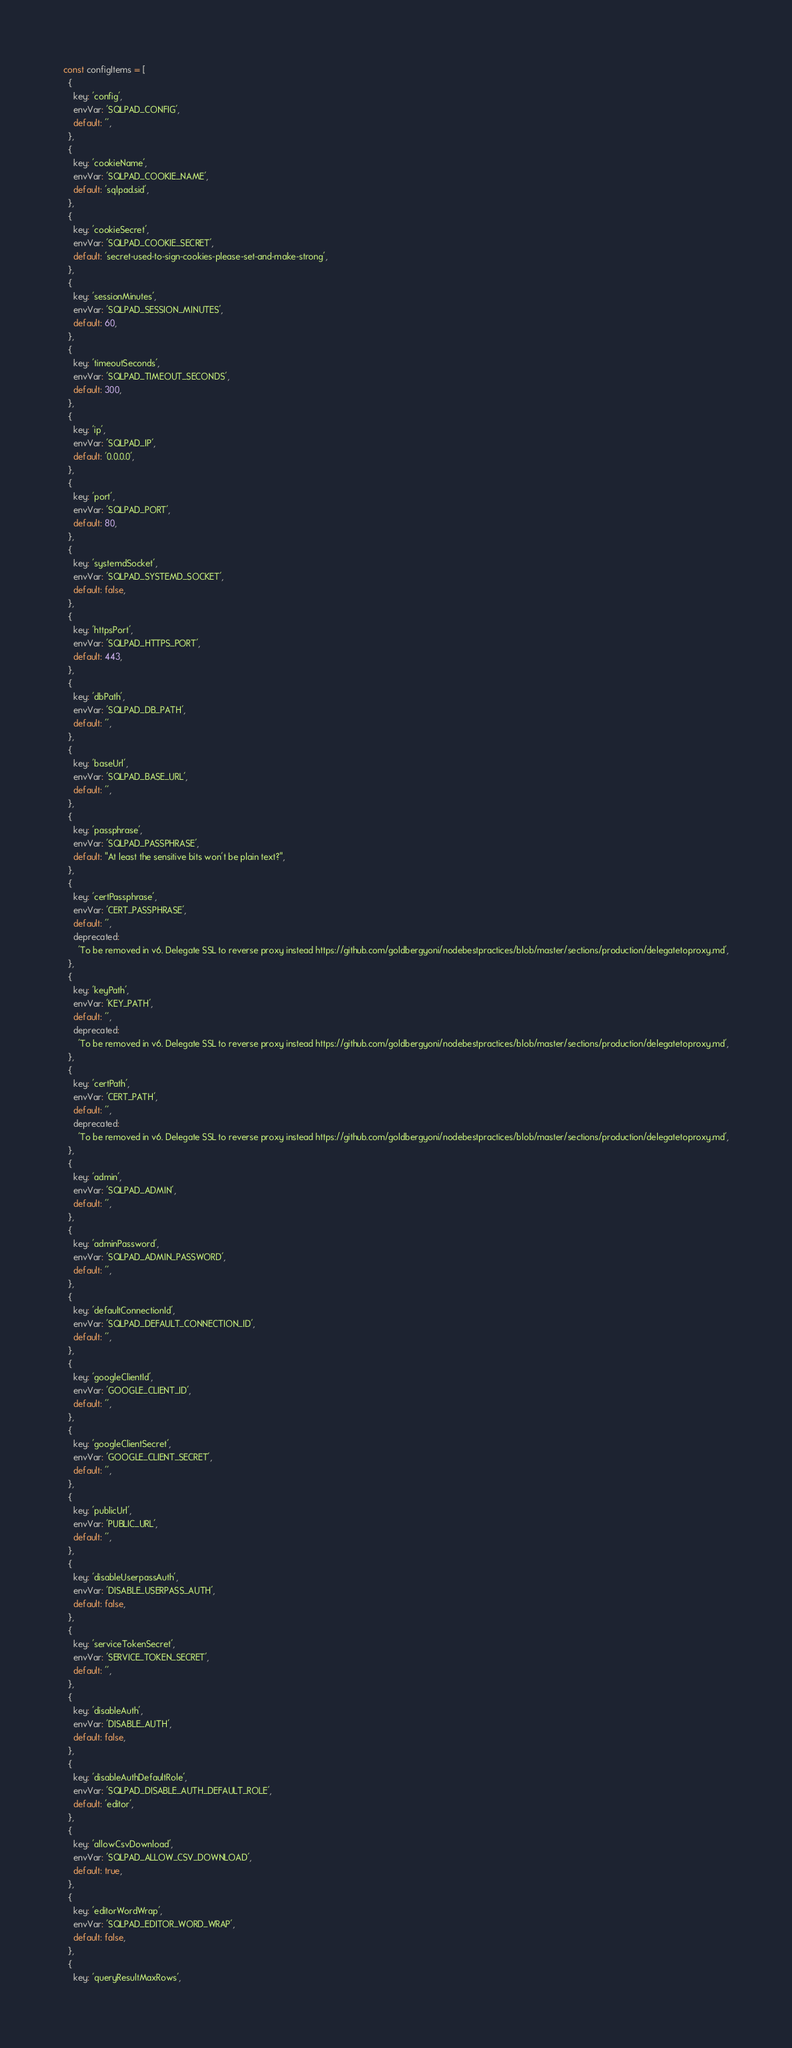Convert code to text. <code><loc_0><loc_0><loc_500><loc_500><_JavaScript_>const configItems = [
  {
    key: 'config',
    envVar: 'SQLPAD_CONFIG',
    default: '',
  },
  {
    key: 'cookieName',
    envVar: 'SQLPAD_COOKIE_NAME',
    default: 'sqlpad.sid',
  },
  {
    key: 'cookieSecret',
    envVar: 'SQLPAD_COOKIE_SECRET',
    default: 'secret-used-to-sign-cookies-please-set-and-make-strong',
  },
  {
    key: 'sessionMinutes',
    envVar: 'SQLPAD_SESSION_MINUTES',
    default: 60,
  },
  {
    key: 'timeoutSeconds',
    envVar: 'SQLPAD_TIMEOUT_SECONDS',
    default: 300,
  },
  {
    key: 'ip',
    envVar: 'SQLPAD_IP',
    default: '0.0.0.0',
  },
  {
    key: 'port',
    envVar: 'SQLPAD_PORT',
    default: 80,
  },
  {
    key: 'systemdSocket',
    envVar: 'SQLPAD_SYSTEMD_SOCKET',
    default: false,
  },
  {
    key: 'httpsPort',
    envVar: 'SQLPAD_HTTPS_PORT',
    default: 443,
  },
  {
    key: 'dbPath',
    envVar: 'SQLPAD_DB_PATH',
    default: '',
  },
  {
    key: 'baseUrl',
    envVar: 'SQLPAD_BASE_URL',
    default: '',
  },
  {
    key: 'passphrase',
    envVar: 'SQLPAD_PASSPHRASE',
    default: "At least the sensitive bits won't be plain text?",
  },
  {
    key: 'certPassphrase',
    envVar: 'CERT_PASSPHRASE',
    default: '',
    deprecated:
      'To be removed in v6. Delegate SSL to reverse proxy instead https://github.com/goldbergyoni/nodebestpractices/blob/master/sections/production/delegatetoproxy.md',
  },
  {
    key: 'keyPath',
    envVar: 'KEY_PATH',
    default: '',
    deprecated:
      'To be removed in v6. Delegate SSL to reverse proxy instead https://github.com/goldbergyoni/nodebestpractices/blob/master/sections/production/delegatetoproxy.md',
  },
  {
    key: 'certPath',
    envVar: 'CERT_PATH',
    default: '',
    deprecated:
      'To be removed in v6. Delegate SSL to reverse proxy instead https://github.com/goldbergyoni/nodebestpractices/blob/master/sections/production/delegatetoproxy.md',
  },
  {
    key: 'admin',
    envVar: 'SQLPAD_ADMIN',
    default: '',
  },
  {
    key: 'adminPassword',
    envVar: 'SQLPAD_ADMIN_PASSWORD',
    default: '',
  },
  {
    key: 'defaultConnectionId',
    envVar: 'SQLPAD_DEFAULT_CONNECTION_ID',
    default: '',
  },
  {
    key: 'googleClientId',
    envVar: 'GOOGLE_CLIENT_ID',
    default: '',
  },
  {
    key: 'googleClientSecret',
    envVar: 'GOOGLE_CLIENT_SECRET',
    default: '',
  },
  {
    key: 'publicUrl',
    envVar: 'PUBLIC_URL',
    default: '',
  },
  {
    key: 'disableUserpassAuth',
    envVar: 'DISABLE_USERPASS_AUTH',
    default: false,
  },
  {
    key: 'serviceTokenSecret',
    envVar: 'SERVICE_TOKEN_SECRET',
    default: '',
  },
  {
    key: 'disableAuth',
    envVar: 'DISABLE_AUTH',
    default: false,
  },
  {
    key: 'disableAuthDefaultRole',
    envVar: 'SQLPAD_DISABLE_AUTH_DEFAULT_ROLE',
    default: 'editor',
  },
  {
    key: 'allowCsvDownload',
    envVar: 'SQLPAD_ALLOW_CSV_DOWNLOAD',
    default: true,
  },
  {
    key: 'editorWordWrap',
    envVar: 'SQLPAD_EDITOR_WORD_WRAP',
    default: false,
  },
  {
    key: 'queryResultMaxRows',</code> 